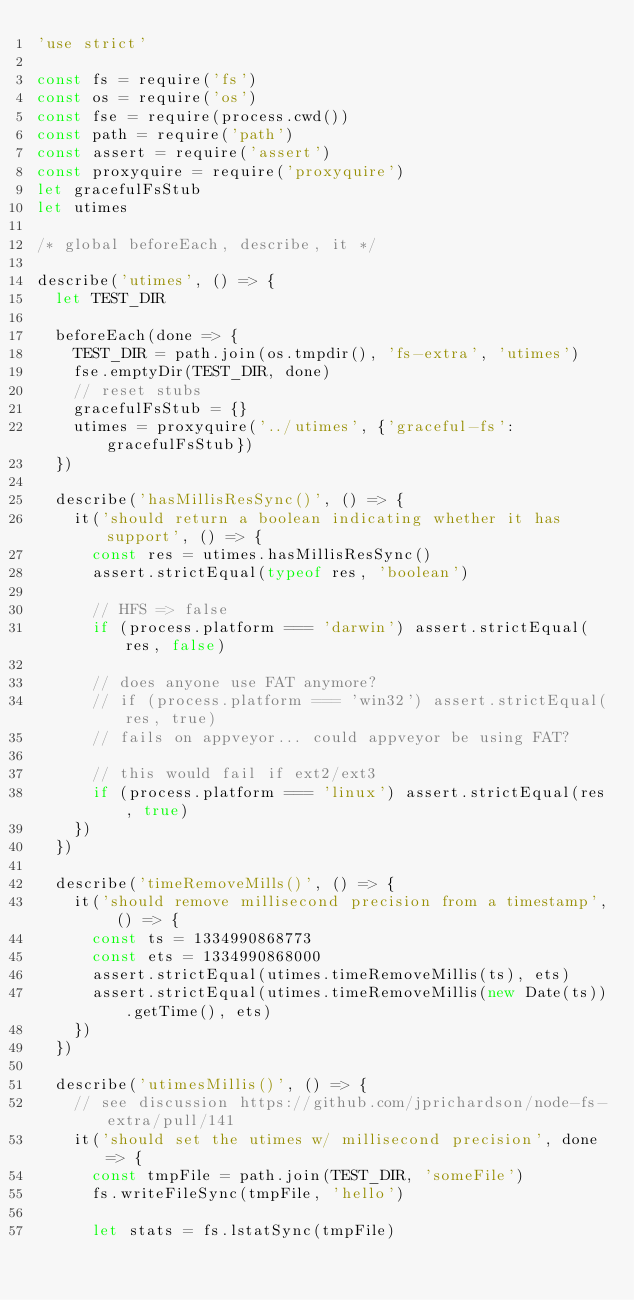<code> <loc_0><loc_0><loc_500><loc_500><_JavaScript_>'use strict'

const fs = require('fs')
const os = require('os')
const fse = require(process.cwd())
const path = require('path')
const assert = require('assert')
const proxyquire = require('proxyquire')
let gracefulFsStub
let utimes

/* global beforeEach, describe, it */

describe('utimes', () => {
  let TEST_DIR

  beforeEach(done => {
    TEST_DIR = path.join(os.tmpdir(), 'fs-extra', 'utimes')
    fse.emptyDir(TEST_DIR, done)
    // reset stubs
    gracefulFsStub = {}
    utimes = proxyquire('../utimes', {'graceful-fs': gracefulFsStub})
  })

  describe('hasMillisResSync()', () => {
    it('should return a boolean indicating whether it has support', () => {
      const res = utimes.hasMillisResSync()
      assert.strictEqual(typeof res, 'boolean')

      // HFS => false
      if (process.platform === 'darwin') assert.strictEqual(res, false)

      // does anyone use FAT anymore?
      // if (process.platform === 'win32') assert.strictEqual(res, true)
      // fails on appveyor... could appveyor be using FAT?

      // this would fail if ext2/ext3
      if (process.platform === 'linux') assert.strictEqual(res, true)
    })
  })

  describe('timeRemoveMills()', () => {
    it('should remove millisecond precision from a timestamp', () => {
      const ts = 1334990868773
      const ets = 1334990868000
      assert.strictEqual(utimes.timeRemoveMillis(ts), ets)
      assert.strictEqual(utimes.timeRemoveMillis(new Date(ts)).getTime(), ets)
    })
  })

  describe('utimesMillis()', () => {
    // see discussion https://github.com/jprichardson/node-fs-extra/pull/141
    it('should set the utimes w/ millisecond precision', done => {
      const tmpFile = path.join(TEST_DIR, 'someFile')
      fs.writeFileSync(tmpFile, 'hello')

      let stats = fs.lstatSync(tmpFile)
</code> 